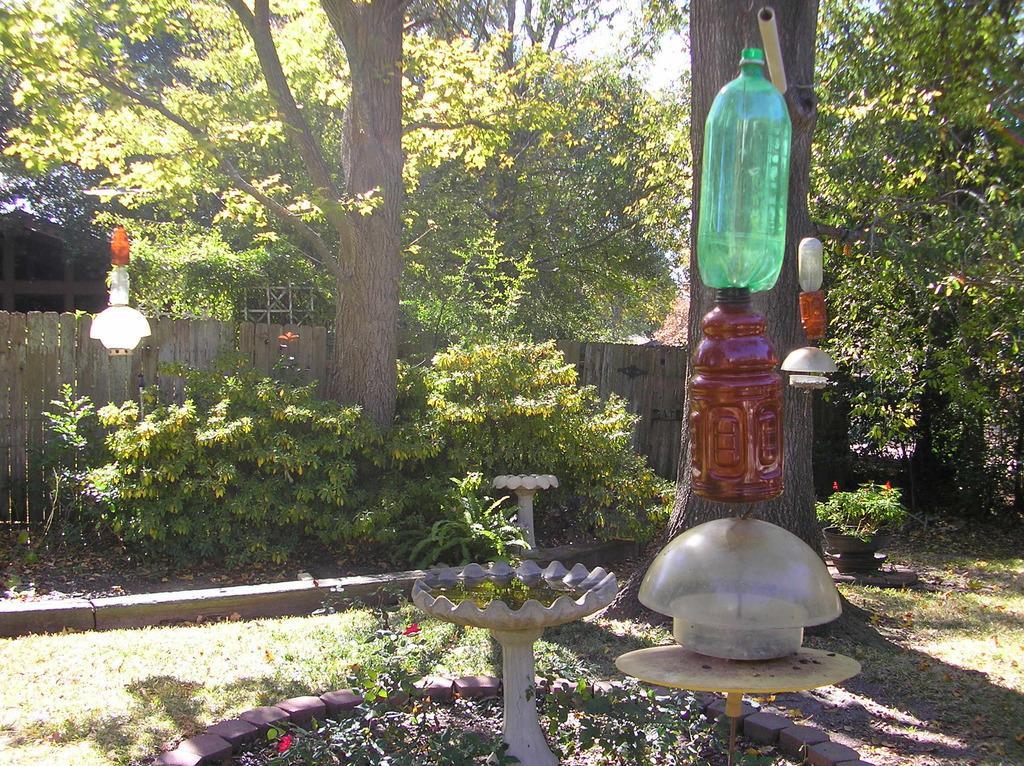Please provide a concise description of this image. In this image bottles are hanged to a tree, in the middle there is a fountain, plants, in the background there are trees and a wooden fencing. 